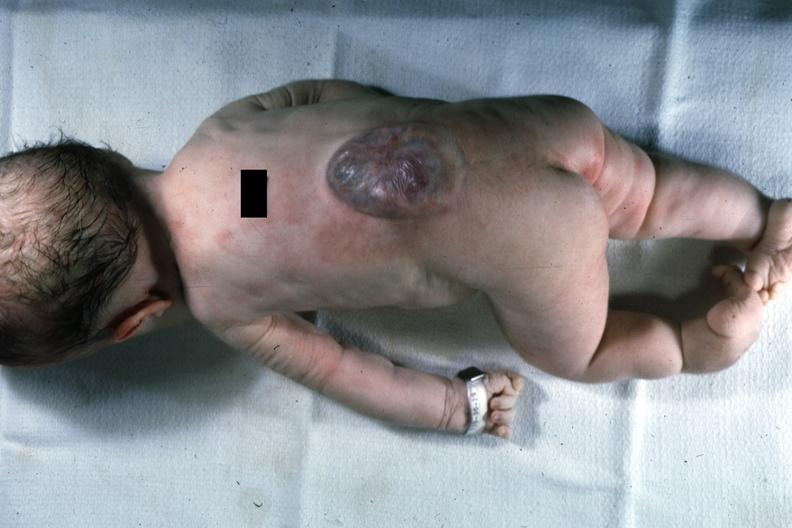what shows typical lesion?
Answer the question using a single word or phrase. This photo of infant from head to toe 